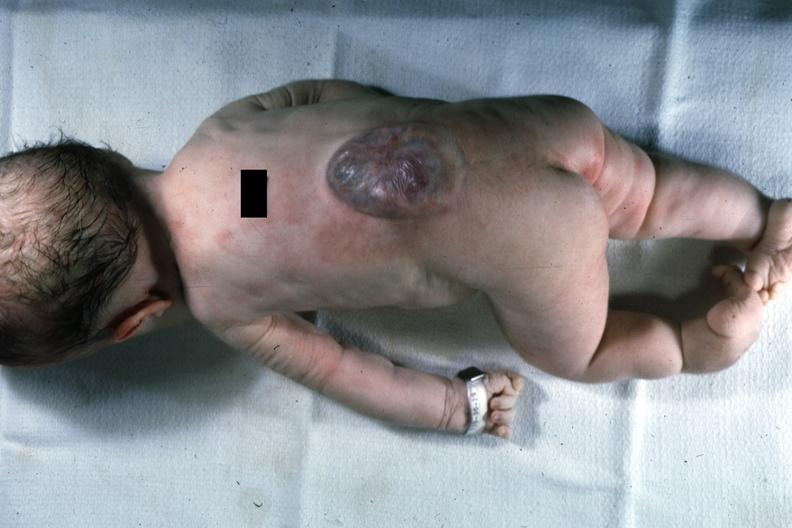what shows typical lesion?
Answer the question using a single word or phrase. This photo of infant from head to toe 